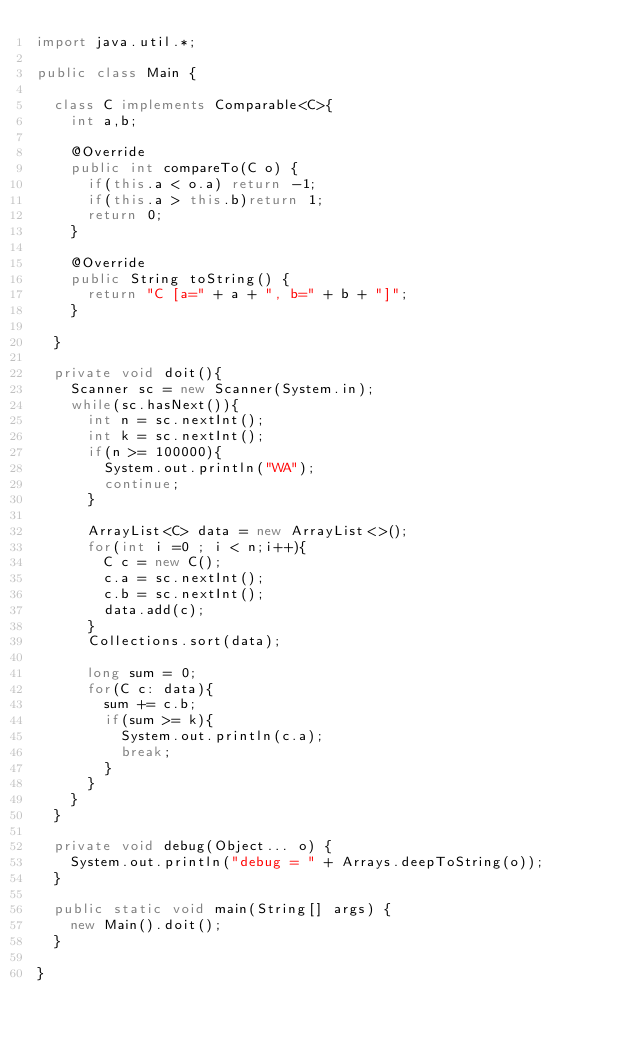<code> <loc_0><loc_0><loc_500><loc_500><_Java_>import java.util.*;

public class Main {
	
	class C implements Comparable<C>{
		int a,b;
		
		@Override
		public int compareTo(C o) {
			if(this.a < o.a) return -1;
			if(this.a > this.b)return 1;
			return 0;
		}

		@Override
		public String toString() {
			return "C [a=" + a + ", b=" + b + "]";
		}
		
	}
	
	private void doit(){
		Scanner sc = new Scanner(System.in);
		while(sc.hasNext()){
			int n = sc.nextInt();
			int k = sc.nextInt();
			if(n >= 100000){
				System.out.println("WA");
				continue;
			}
			
			ArrayList<C> data = new ArrayList<>();
			for(int i =0 ; i < n;i++){
				C c = new C();
				c.a = sc.nextInt();
				c.b = sc.nextInt();
				data.add(c);
			}
			Collections.sort(data);
			
			long sum = 0;
			for(C c: data){
				sum += c.b;
				if(sum >= k){
					System.out.println(c.a);
					break;
				}
			}
		}
	}

	private void debug(Object... o) {
		System.out.println("debug = " + Arrays.deepToString(o));
	}

	public static void main(String[] args) {
		new Main().doit();
	}

}
</code> 